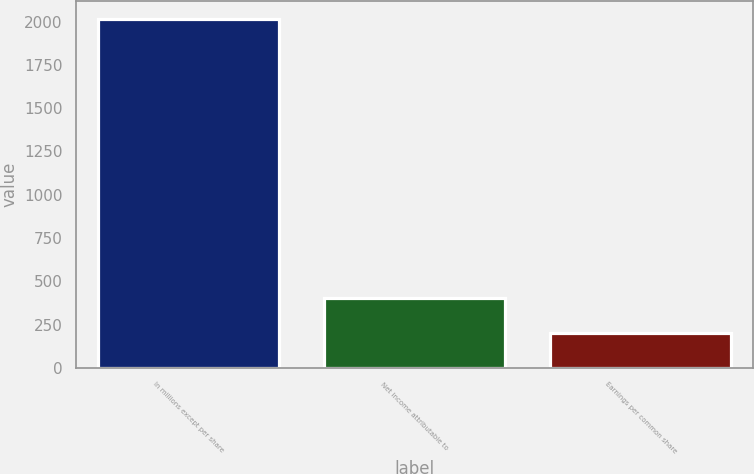Convert chart to OTSL. <chart><loc_0><loc_0><loc_500><loc_500><bar_chart><fcel>In millions except per share<fcel>Net income attributable to<fcel>Earnings per common share<nl><fcel>2016<fcel>404.69<fcel>203.28<nl></chart> 